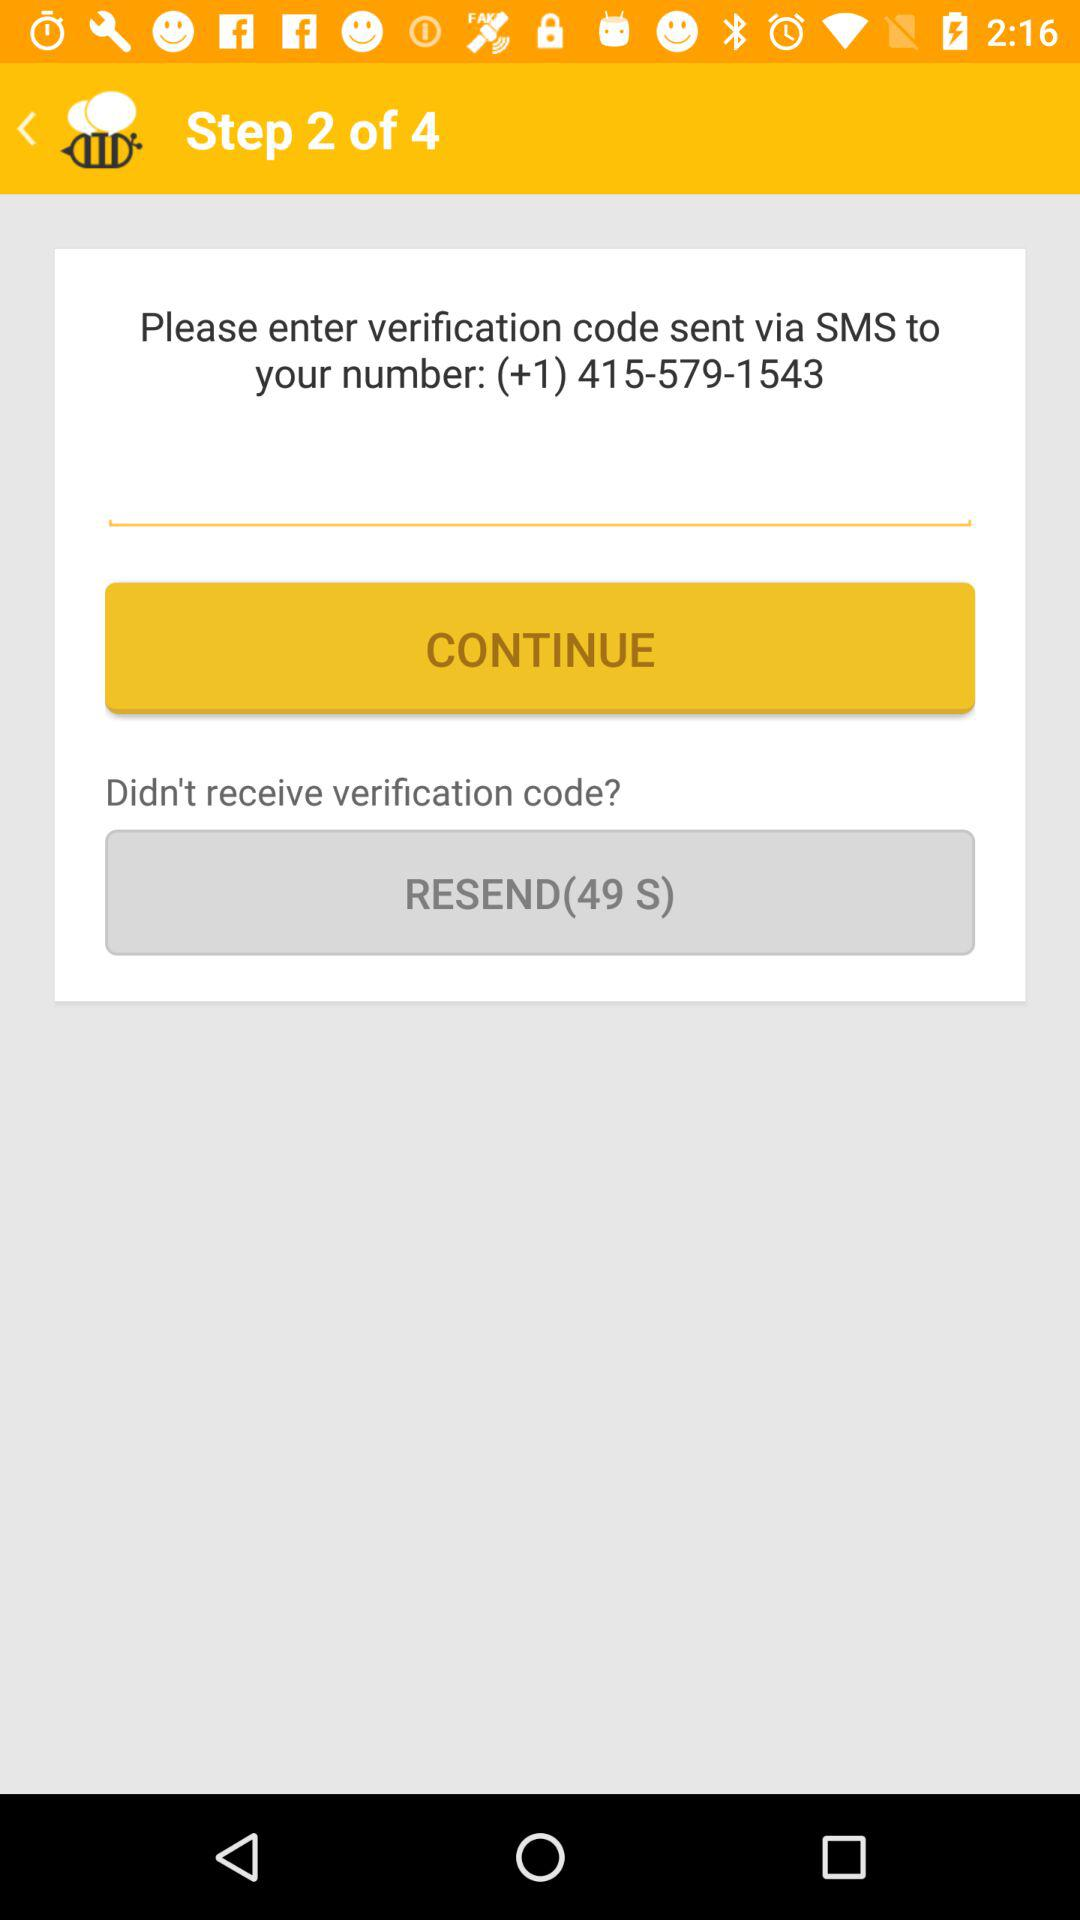How many seconds are left until the verification code can be resent?
Answer the question using a single word or phrase. 49 